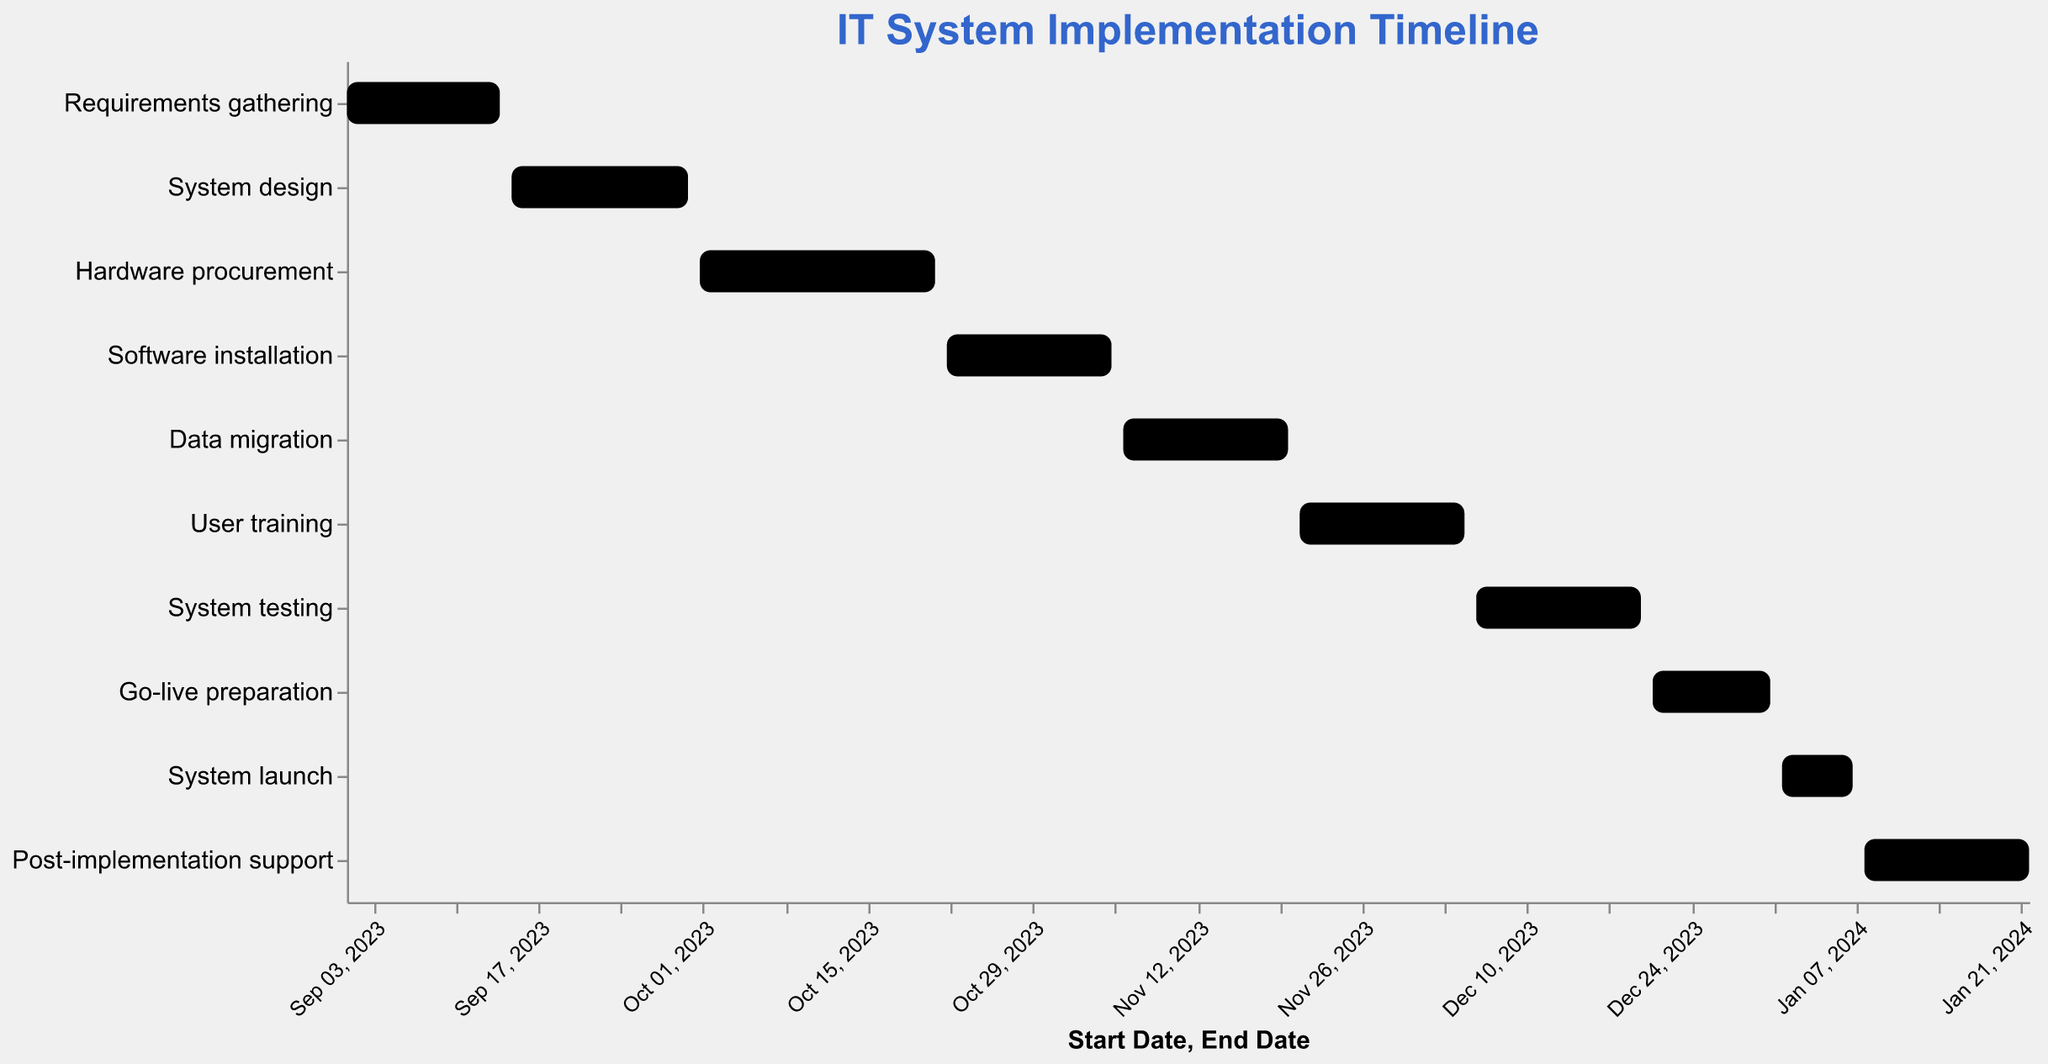When does the "System design" task start? Look at the "System design" bar and note the "Start Date" displayed in the tooltip or along the x-axis.
Answer: September 15, 2023 What task has the shortest duration? Compare the "Duration (days)" values of all tasks, noting which one is the smallest.
Answer: System launch Which task spans the entire month of December 2023? Identify the tasks that start in December 2023 and end within the same month. Multiple tasks may start in December but only one should span the entire month.
Answer: System testing What are the starting and ending dates for the "User training" task? Hover over the "User training" bar or refer to the x-axis to get the exact "Start Date" and "End Date" displayed.
Answer: November 21, 2023 - December 5, 2023 Which task has the longest duration? Compare the "Duration (days)" values of all tasks, noting which one is the largest.
Answer: Hardware procurement How many tasks have a duration of 15 days? Review the "Duration (days)" values for each task and count the number of tasks that have a duration of 15 days.
Answer: 5 Which tasks start and end within November 2023? Check the "Start Date" and "End Date" of each task to determine which ones fall entirely within November 2023.
Answer: Data migration, User training What task follows directly after "Software installation"? Look at the "End Date" of "Software installation" and then find the task that starts immediately afterward.
Answer: Data migration How many tasks are scheduled to begin in 2024? Check the "Start Date" of each task and count the number of tasks that begin in 2024.
Answer: 3 What is the total duration of the entire project? Determine the "Start Date" of the first task and the "End Date" of the last task. Calculate the total number of days from the start to the end.
Answer: 144 days 